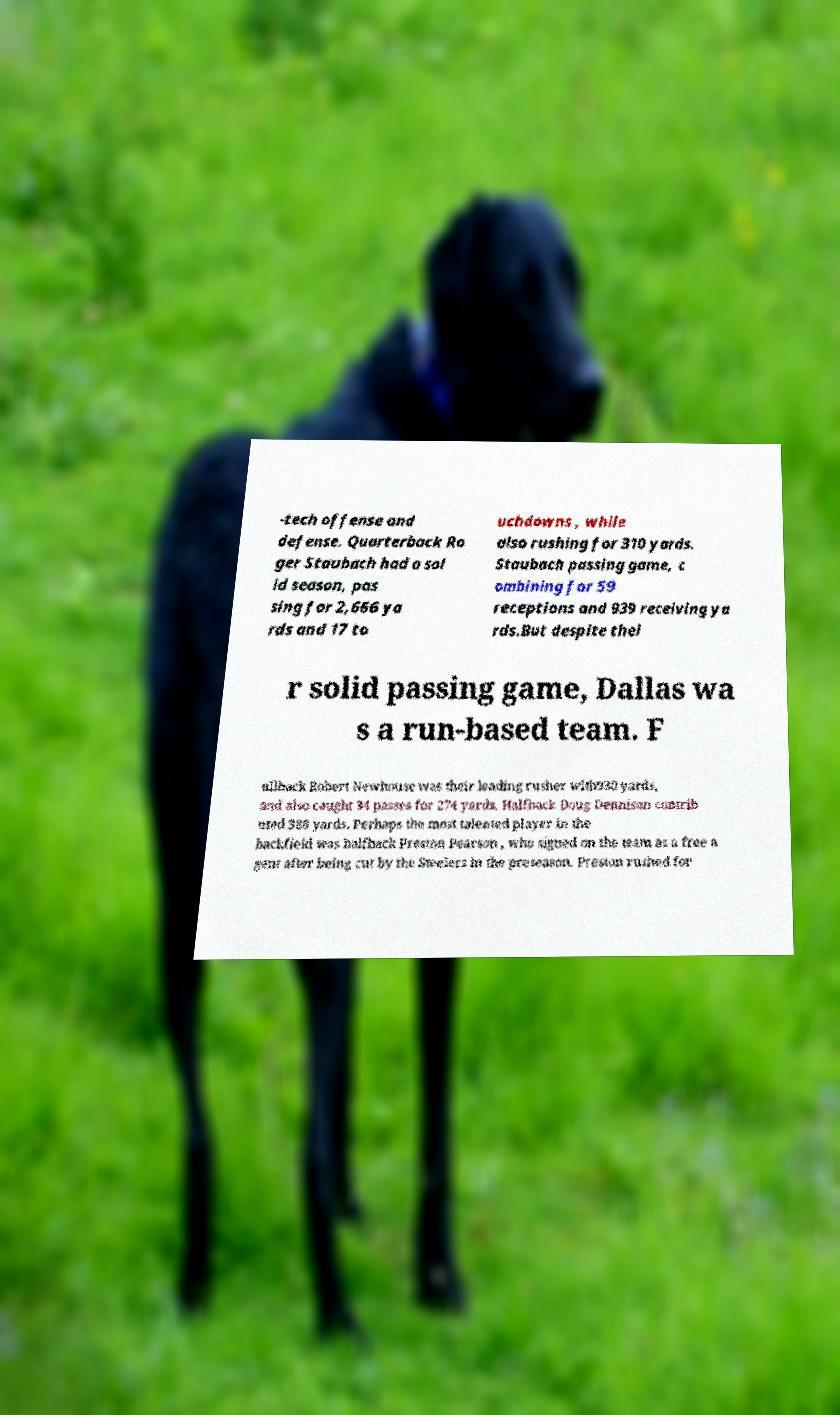For documentation purposes, I need the text within this image transcribed. Could you provide that? -tech offense and defense. Quarterback Ro ger Staubach had a sol id season, pas sing for 2,666 ya rds and 17 to uchdowns , while also rushing for 310 yards. Staubach passing game, c ombining for 59 receptions and 939 receiving ya rds.But despite thei r solid passing game, Dallas wa s a run-based team. F ullback Robert Newhouse was their leading rusher with930 yards, and also caught 34 passes for 274 yards. Halfback Doug Dennison contrib uted 388 yards. Perhaps the most talented player in the backfield was halfback Preston Pearson , who signed on the team as a free a gent after being cut by the Steelers in the preseason. Preston rushed for 